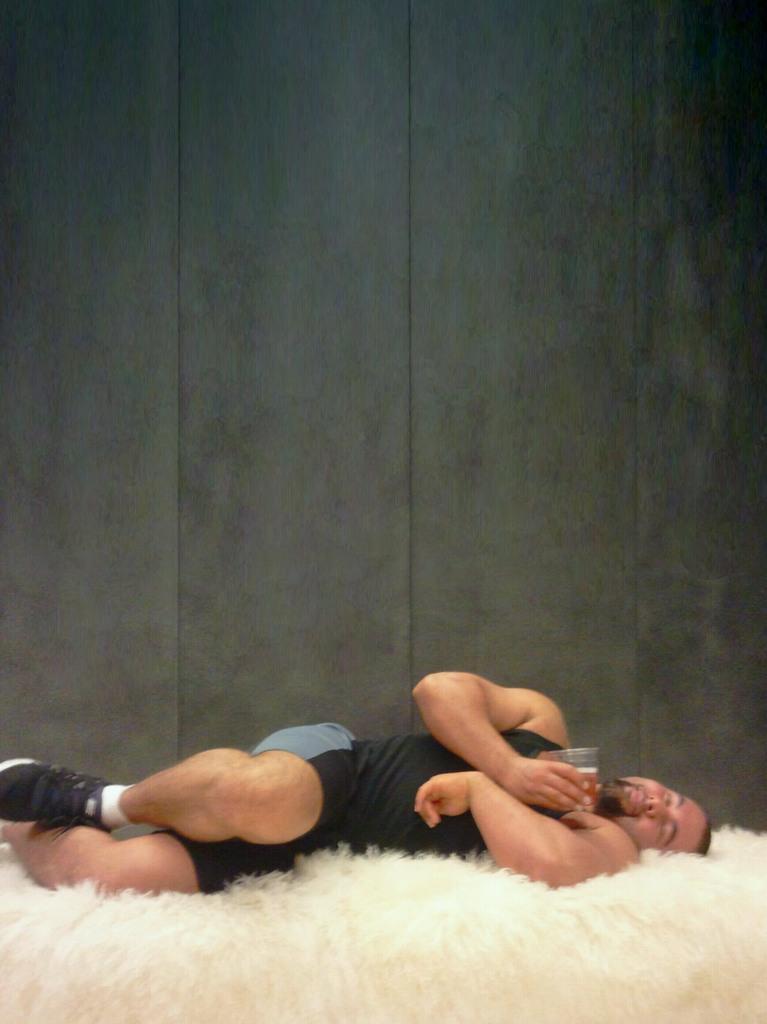How would you summarize this image in a sentence or two? In this image there is a man sleeping on a bed. He is holding a glass in the hand. Behind him there is wall. At the bottom there is the fur. 